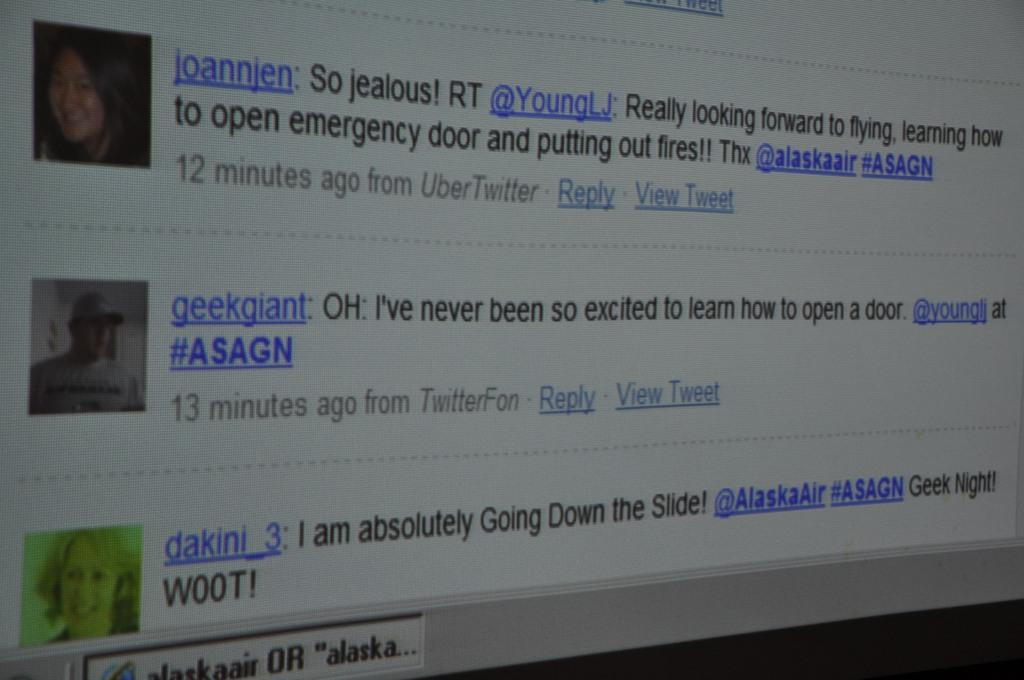What is the main object in the image? There is a screen in the image. What can be seen on the screen? Three persons' faces are visible on the screen. Is there any text or writing on the screen? Yes, there is text or writing on the screen. What type of vegetable is being used as a prop by one of the persons on the screen? There is no vegetable present in the image, and no person is holding a prop. 